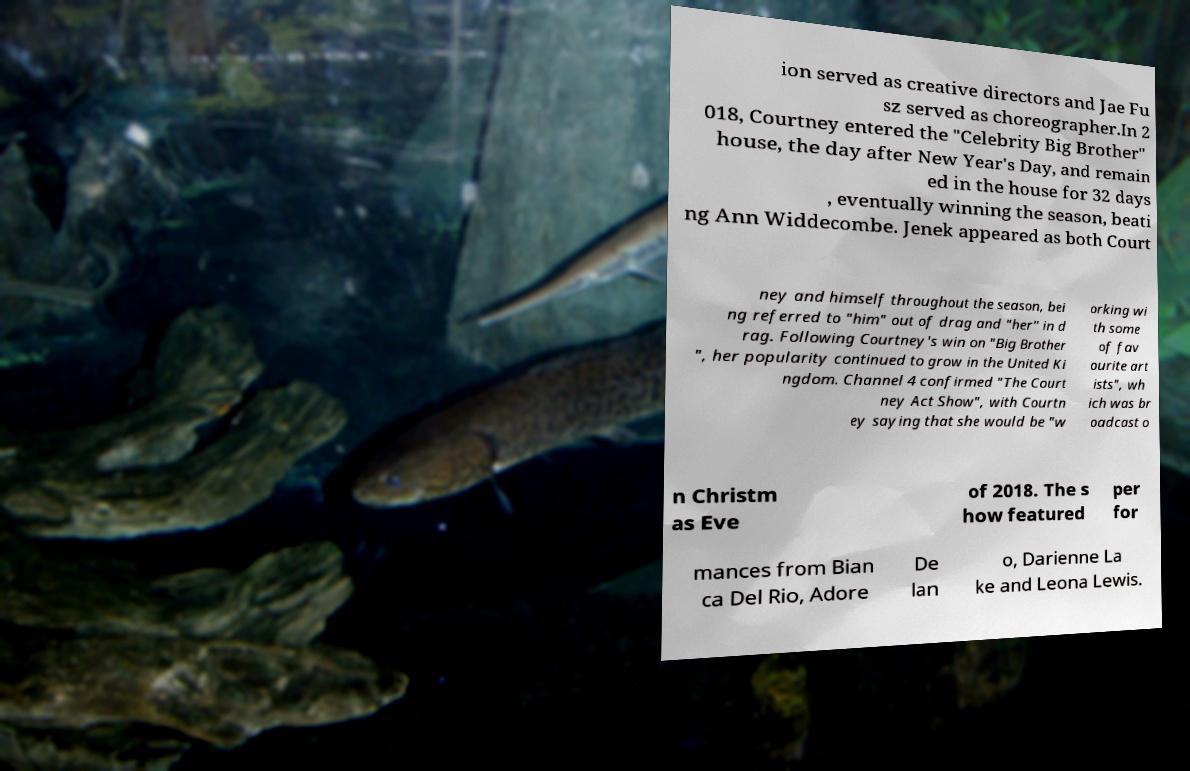Could you assist in decoding the text presented in this image and type it out clearly? ion served as creative directors and Jae Fu sz served as choreographer.In 2 018, Courtney entered the "Celebrity Big Brother" house, the day after New Year's Day, and remain ed in the house for 32 days , eventually winning the season, beati ng Ann Widdecombe. Jenek appeared as both Court ney and himself throughout the season, bei ng referred to "him" out of drag and "her" in d rag. Following Courtney's win on "Big Brother ", her popularity continued to grow in the United Ki ngdom. Channel 4 confirmed "The Court ney Act Show", with Courtn ey saying that she would be "w orking wi th some of fav ourite art ists", wh ich was br oadcast o n Christm as Eve of 2018. The s how featured per for mances from Bian ca Del Rio, Adore De lan o, Darienne La ke and Leona Lewis. 